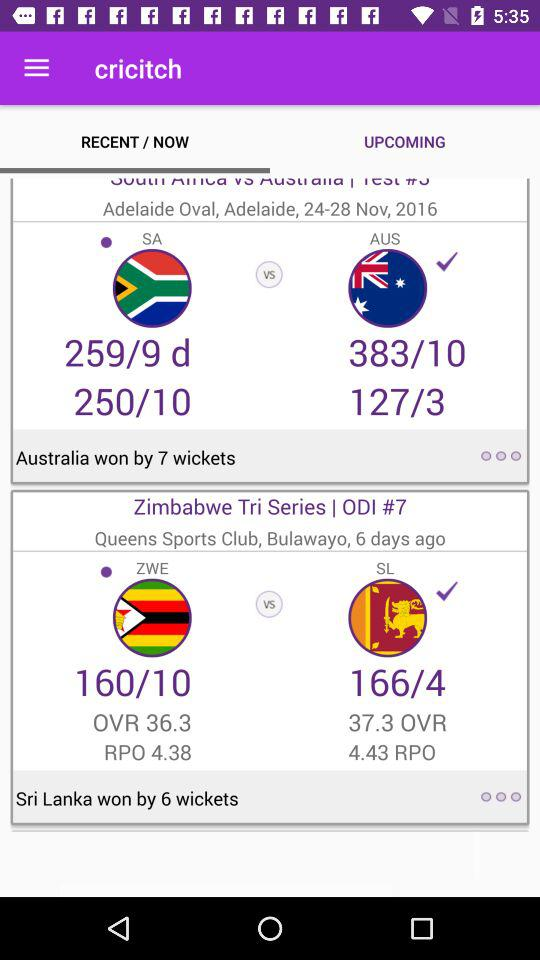What date range is shown? The shown date range is from 24 to 28 November 2016. 